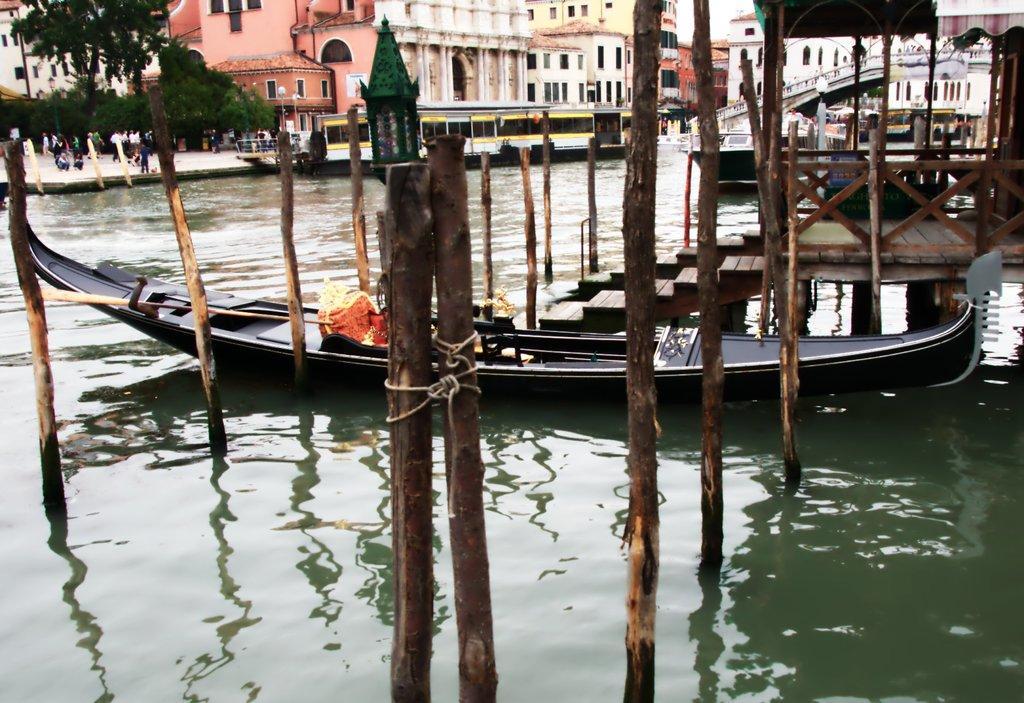Can you describe this image briefly? In the center of the image there are sticks and boat on the water. On the right side of the image there are stairs, boat and building. On the left side of the image there are trees, persons and boat. In the background there is a sky. 